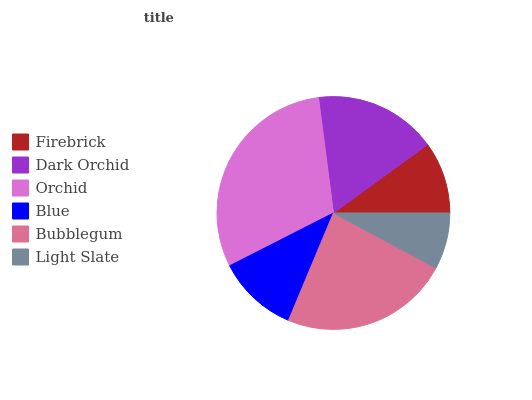Is Light Slate the minimum?
Answer yes or no. Yes. Is Orchid the maximum?
Answer yes or no. Yes. Is Dark Orchid the minimum?
Answer yes or no. No. Is Dark Orchid the maximum?
Answer yes or no. No. Is Dark Orchid greater than Firebrick?
Answer yes or no. Yes. Is Firebrick less than Dark Orchid?
Answer yes or no. Yes. Is Firebrick greater than Dark Orchid?
Answer yes or no. No. Is Dark Orchid less than Firebrick?
Answer yes or no. No. Is Dark Orchid the high median?
Answer yes or no. Yes. Is Blue the low median?
Answer yes or no. Yes. Is Bubblegum the high median?
Answer yes or no. No. Is Bubblegum the low median?
Answer yes or no. No. 